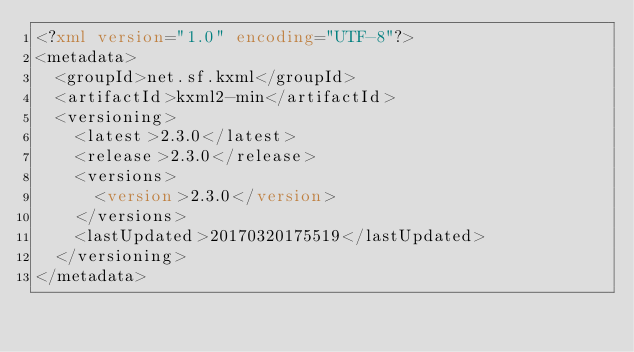Convert code to text. <code><loc_0><loc_0><loc_500><loc_500><_XML_><?xml version="1.0" encoding="UTF-8"?>
<metadata>
  <groupId>net.sf.kxml</groupId>
  <artifactId>kxml2-min</artifactId>
  <versioning>
    <latest>2.3.0</latest>
    <release>2.3.0</release>
    <versions>
      <version>2.3.0</version>
    </versions>
    <lastUpdated>20170320175519</lastUpdated>
  </versioning>
</metadata>
</code> 